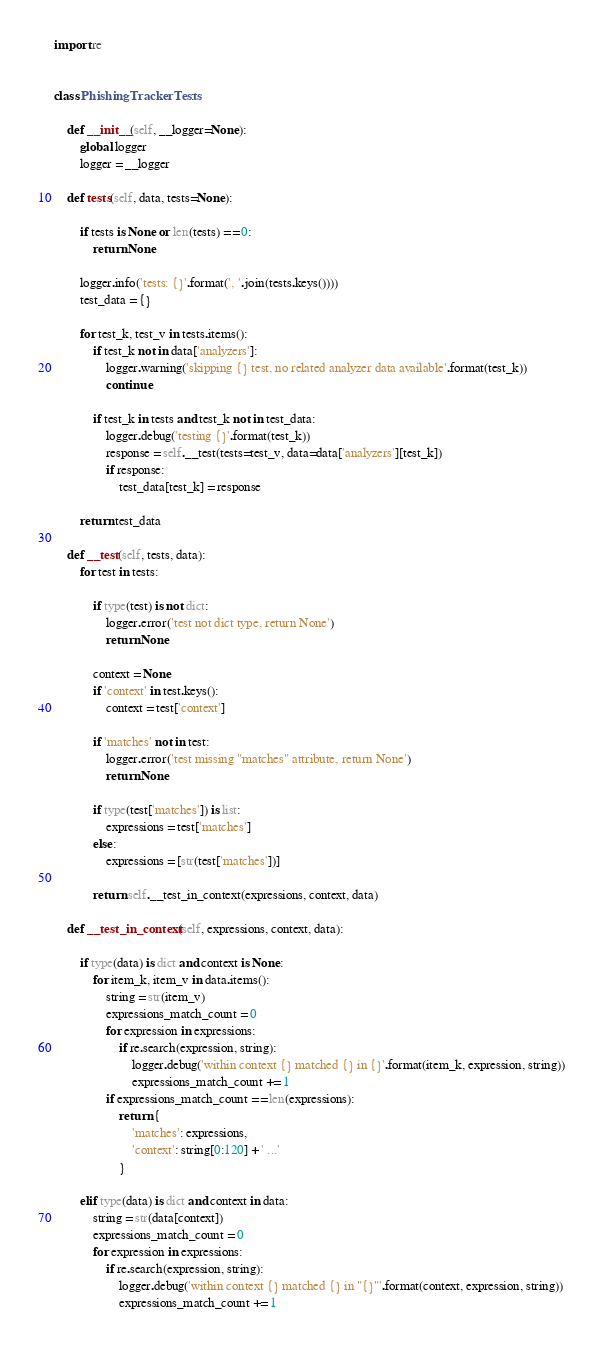<code> <loc_0><loc_0><loc_500><loc_500><_Python_>
import re


class PhishingTrackerTests:

    def __init__(self, __logger=None):
        global logger
        logger = __logger

    def tests(self, data, tests=None):

        if tests is None or len(tests) == 0:
            return None

        logger.info('tests: {}'.format(', '.join(tests.keys())))
        test_data = {}

        for test_k, test_v in tests.items():
            if test_k not in data['analyzers']:
                logger.warning('skipping {} test, no related analyzer data available'.format(test_k))
                continue

            if test_k in tests and test_k not in test_data:
                logger.debug('testing {}'.format(test_k))
                response = self.__test(tests=test_v, data=data['analyzers'][test_k])
                if response:
                    test_data[test_k] = response

        return test_data

    def __test(self, tests, data):
        for test in tests:

            if type(test) is not dict:
                logger.error('test not dict type, return None')
                return None

            context = None
            if 'context' in test.keys():
                context = test['context']

            if 'matches' not in test:
                logger.error('test missing "matches" attribute, return None')
                return None

            if type(test['matches']) is list:
                expressions = test['matches']
            else:
                expressions = [str(test['matches'])]

            return self.__test_in_context(expressions, context, data)

    def __test_in_context(self, expressions, context, data):

        if type(data) is dict and context is None:
            for item_k, item_v in data.items():
                string = str(item_v)
                expressions_match_count = 0
                for expression in expressions:
                    if re.search(expression, string):
                        logger.debug('within context {} matched {} in {}'.format(item_k, expression, string))
                        expressions_match_count += 1
                if expressions_match_count == len(expressions):
                    return {
                        'matches': expressions,
                        'context': string[0:120] + ' ...'
                    }

        elif type(data) is dict and context in data:
            string = str(data[context])
            expressions_match_count = 0
            for expression in expressions:
                if re.search(expression, string):
                    logger.debug('within context {} matched {} in "{}"'.format(context, expression, string))
                    expressions_match_count += 1</code> 